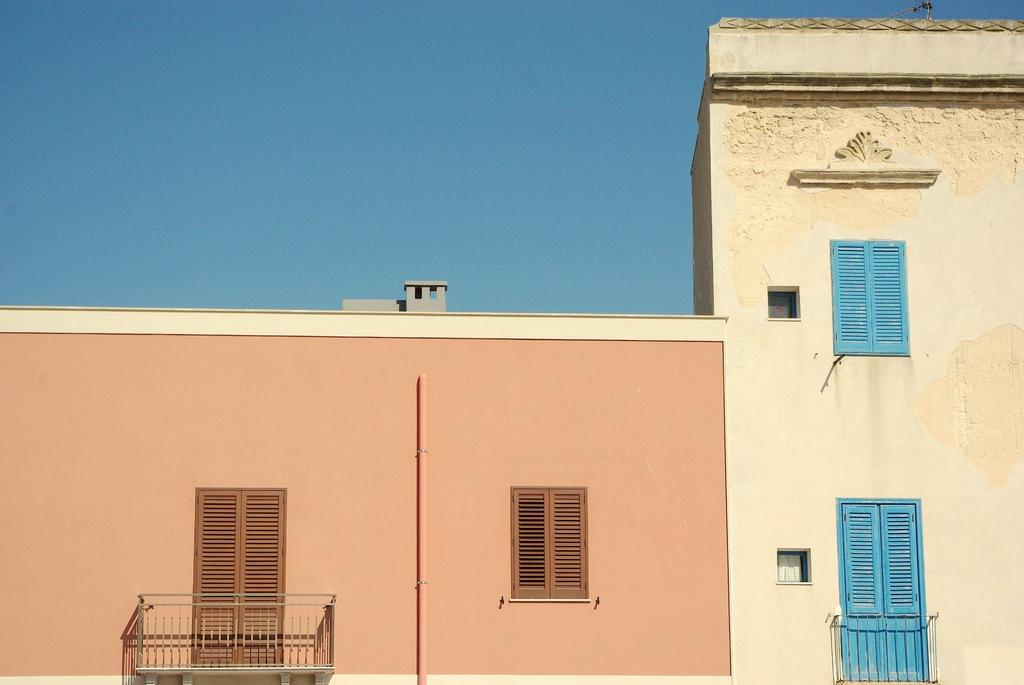What type of structure is visible in the image? There is a building with windows in the image. What is in front of the windows of the building? There is a metal fence in front of the windows. What can be seen in the background of the image? The sky is visible in the background of the image. How many horses are running in the image? There are no horses present in the image. What type of motion is the building exhibiting in the image? The building is stationary in the image; it is not exhibiting any motion. 